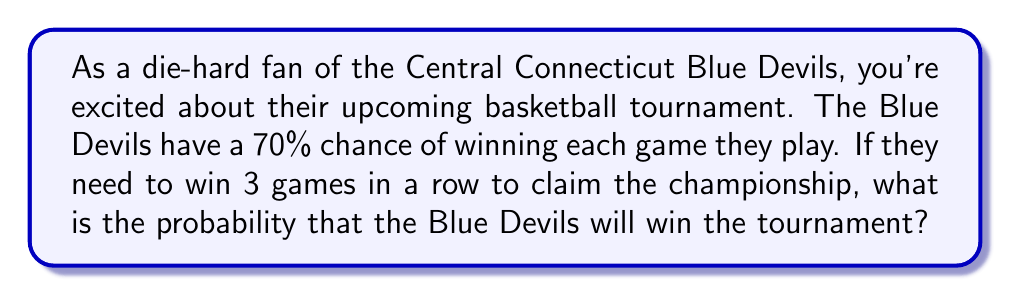Help me with this question. Let's approach this step-by-step:

1) First, we need to understand what it means for the Blue Devils to win the tournament. They must win all 3 games in a row.

2) The probability of winning each game is 70% or 0.7.

3) Since the events (winning each game) are independent, we can use the multiplication rule of probability. This states that for independent events, the probability of all events occurring is the product of their individual probabilities.

4) Let's define our events:
   $A$ = Blue Devils win game 1
   $B$ = Blue Devils win game 2
   $C$ = Blue Devils win game 3

5) We want to find $P(A \text{ and } B \text{ and } C)$

6) Using the multiplication rule:

   $$P(A \text{ and } B \text{ and } C) = P(A) \times P(B) \times P(C)$$

7) Substituting the probabilities:

   $$P(A \text{ and } B \text{ and } C) = 0.7 \times 0.7 \times 0.7$$

8) Calculating:

   $$P(A \text{ and } B \text{ and } C) = 0.7^3 = 0.343$$

9) Converting to a percentage:

   $$0.343 \times 100\% = 34.3\%$$

Therefore, the probability that the Blue Devils will win the tournament is approximately 34.3%.
Answer: The probability that the Central Connecticut Blue Devils will win the tournament is 34.3%. 